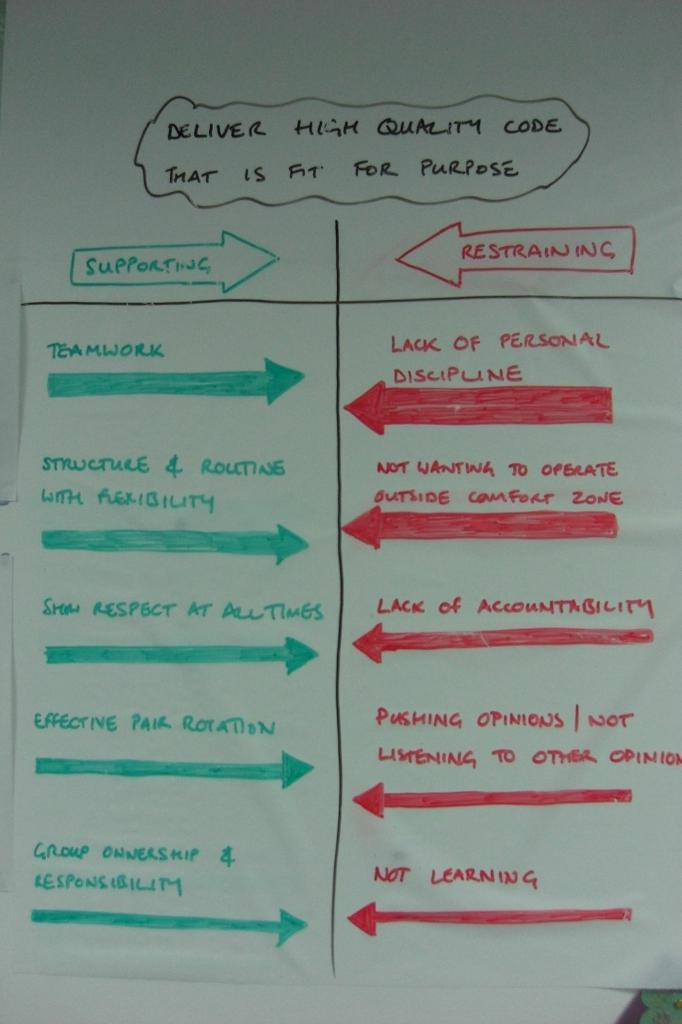<image>
Share a concise interpretation of the image provided. White board that has a green arrow which says "Supporting" in it. 